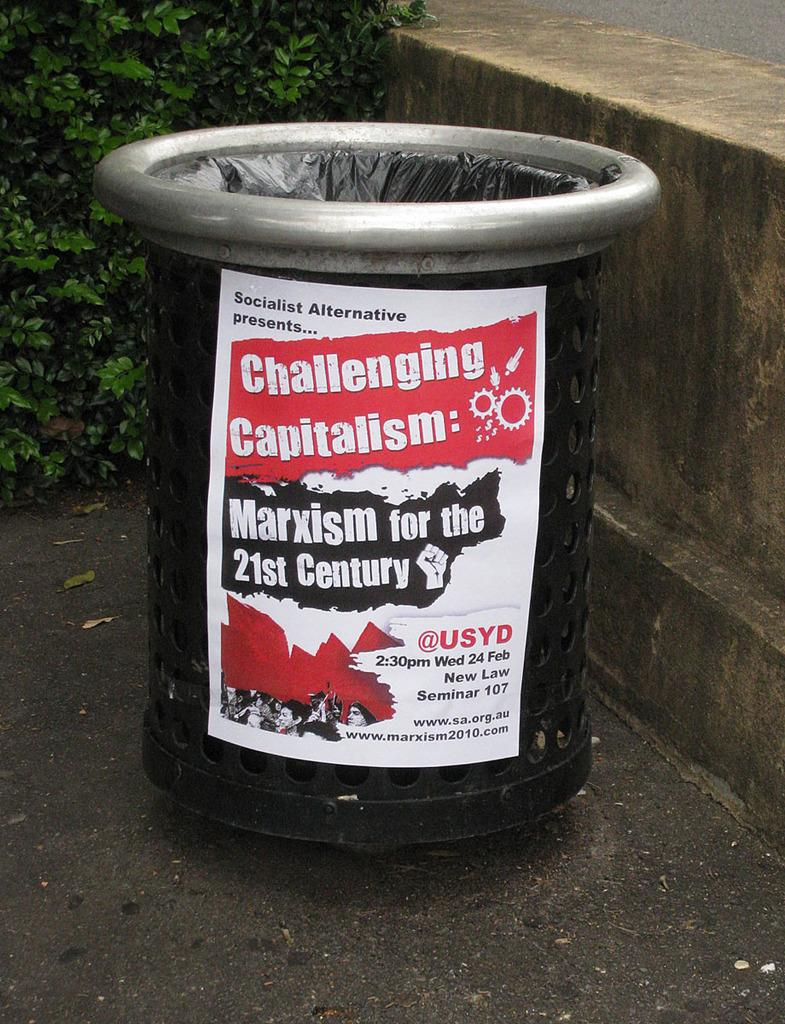What is the main object in the foreground of the image? There is a poster-like object in the foreground of the image. Where is the object located? The object is on the road. What can be seen in the background of the image? There is a tiny wall and plants in the background of the image. How does the stranger interact with the sponge in the quiet environment of the image? There is no stranger, sponge, or indication of a quiet environment present in the image. 